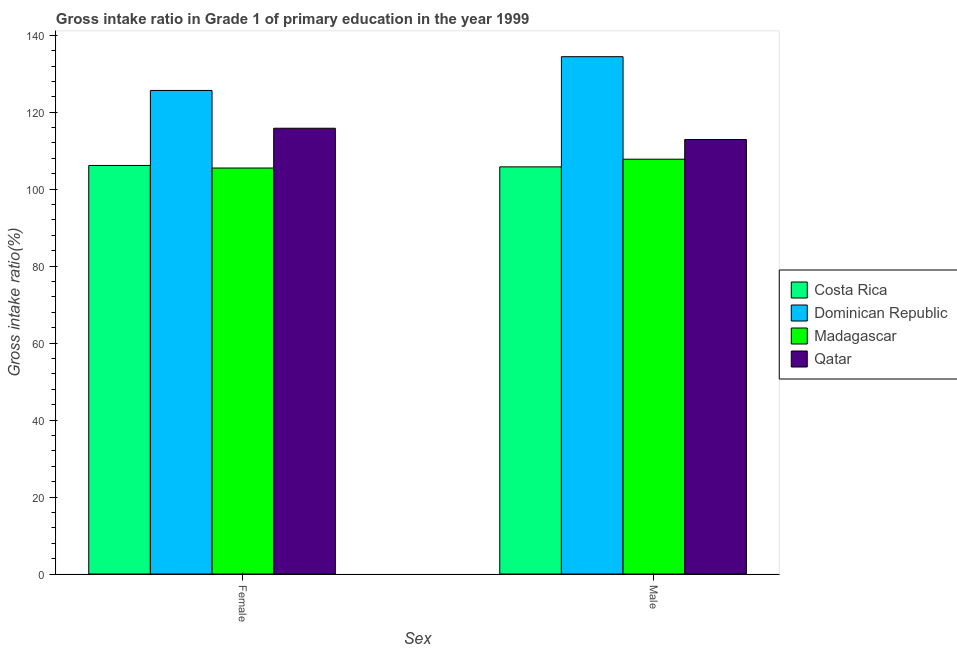How many different coloured bars are there?
Provide a succinct answer. 4. How many groups of bars are there?
Ensure brevity in your answer.  2. Are the number of bars per tick equal to the number of legend labels?
Offer a terse response. Yes. What is the gross intake ratio(male) in Qatar?
Ensure brevity in your answer.  112.9. Across all countries, what is the maximum gross intake ratio(female)?
Offer a terse response. 125.65. Across all countries, what is the minimum gross intake ratio(male)?
Provide a succinct answer. 105.8. In which country was the gross intake ratio(male) maximum?
Ensure brevity in your answer.  Dominican Republic. In which country was the gross intake ratio(female) minimum?
Provide a short and direct response. Madagascar. What is the total gross intake ratio(male) in the graph?
Provide a short and direct response. 460.91. What is the difference between the gross intake ratio(female) in Dominican Republic and that in Qatar?
Ensure brevity in your answer.  9.82. What is the difference between the gross intake ratio(male) in Dominican Republic and the gross intake ratio(female) in Madagascar?
Ensure brevity in your answer.  28.93. What is the average gross intake ratio(male) per country?
Make the answer very short. 115.23. What is the difference between the gross intake ratio(male) and gross intake ratio(female) in Dominican Republic?
Provide a short and direct response. 8.77. In how many countries, is the gross intake ratio(female) greater than 100 %?
Your response must be concise. 4. What is the ratio of the gross intake ratio(female) in Madagascar to that in Costa Rica?
Offer a very short reply. 0.99. What does the 3rd bar from the left in Female represents?
Provide a succinct answer. Madagascar. How many bars are there?
Ensure brevity in your answer.  8. Are all the bars in the graph horizontal?
Your answer should be very brief. No. How many countries are there in the graph?
Keep it short and to the point. 4. What is the difference between two consecutive major ticks on the Y-axis?
Make the answer very short. 20. Does the graph contain grids?
Offer a terse response. No. Where does the legend appear in the graph?
Your answer should be very brief. Center right. How many legend labels are there?
Your answer should be compact. 4. How are the legend labels stacked?
Your response must be concise. Vertical. What is the title of the graph?
Keep it short and to the point. Gross intake ratio in Grade 1 of primary education in the year 1999. What is the label or title of the X-axis?
Provide a succinct answer. Sex. What is the label or title of the Y-axis?
Keep it short and to the point. Gross intake ratio(%). What is the Gross intake ratio(%) in Costa Rica in Female?
Make the answer very short. 106.16. What is the Gross intake ratio(%) of Dominican Republic in Female?
Provide a succinct answer. 125.65. What is the Gross intake ratio(%) of Madagascar in Female?
Ensure brevity in your answer.  105.5. What is the Gross intake ratio(%) in Qatar in Female?
Your answer should be very brief. 115.83. What is the Gross intake ratio(%) of Costa Rica in Male?
Make the answer very short. 105.8. What is the Gross intake ratio(%) of Dominican Republic in Male?
Offer a very short reply. 134.42. What is the Gross intake ratio(%) of Madagascar in Male?
Give a very brief answer. 107.79. What is the Gross intake ratio(%) in Qatar in Male?
Your response must be concise. 112.9. Across all Sex, what is the maximum Gross intake ratio(%) in Costa Rica?
Your answer should be very brief. 106.16. Across all Sex, what is the maximum Gross intake ratio(%) in Dominican Republic?
Your response must be concise. 134.42. Across all Sex, what is the maximum Gross intake ratio(%) in Madagascar?
Offer a terse response. 107.79. Across all Sex, what is the maximum Gross intake ratio(%) in Qatar?
Your response must be concise. 115.83. Across all Sex, what is the minimum Gross intake ratio(%) of Costa Rica?
Your answer should be compact. 105.8. Across all Sex, what is the minimum Gross intake ratio(%) in Dominican Republic?
Your answer should be compact. 125.65. Across all Sex, what is the minimum Gross intake ratio(%) in Madagascar?
Provide a succinct answer. 105.5. Across all Sex, what is the minimum Gross intake ratio(%) in Qatar?
Offer a very short reply. 112.9. What is the total Gross intake ratio(%) of Costa Rica in the graph?
Offer a very short reply. 211.96. What is the total Gross intake ratio(%) of Dominican Republic in the graph?
Your answer should be very brief. 260.08. What is the total Gross intake ratio(%) of Madagascar in the graph?
Your response must be concise. 213.28. What is the total Gross intake ratio(%) of Qatar in the graph?
Your answer should be compact. 228.73. What is the difference between the Gross intake ratio(%) of Costa Rica in Female and that in Male?
Ensure brevity in your answer.  0.37. What is the difference between the Gross intake ratio(%) in Dominican Republic in Female and that in Male?
Your answer should be very brief. -8.77. What is the difference between the Gross intake ratio(%) of Madagascar in Female and that in Male?
Offer a very short reply. -2.29. What is the difference between the Gross intake ratio(%) of Qatar in Female and that in Male?
Give a very brief answer. 2.93. What is the difference between the Gross intake ratio(%) of Costa Rica in Female and the Gross intake ratio(%) of Dominican Republic in Male?
Ensure brevity in your answer.  -28.26. What is the difference between the Gross intake ratio(%) of Costa Rica in Female and the Gross intake ratio(%) of Madagascar in Male?
Your answer should be very brief. -1.63. What is the difference between the Gross intake ratio(%) of Costa Rica in Female and the Gross intake ratio(%) of Qatar in Male?
Make the answer very short. -6.74. What is the difference between the Gross intake ratio(%) of Dominican Republic in Female and the Gross intake ratio(%) of Madagascar in Male?
Offer a very short reply. 17.87. What is the difference between the Gross intake ratio(%) of Dominican Republic in Female and the Gross intake ratio(%) of Qatar in Male?
Provide a short and direct response. 12.75. What is the difference between the Gross intake ratio(%) in Madagascar in Female and the Gross intake ratio(%) in Qatar in Male?
Your answer should be compact. -7.41. What is the average Gross intake ratio(%) in Costa Rica per Sex?
Ensure brevity in your answer.  105.98. What is the average Gross intake ratio(%) in Dominican Republic per Sex?
Give a very brief answer. 130.04. What is the average Gross intake ratio(%) of Madagascar per Sex?
Offer a very short reply. 106.64. What is the average Gross intake ratio(%) in Qatar per Sex?
Offer a very short reply. 114.37. What is the difference between the Gross intake ratio(%) of Costa Rica and Gross intake ratio(%) of Dominican Republic in Female?
Provide a succinct answer. -19.49. What is the difference between the Gross intake ratio(%) in Costa Rica and Gross intake ratio(%) in Madagascar in Female?
Your answer should be very brief. 0.67. What is the difference between the Gross intake ratio(%) in Costa Rica and Gross intake ratio(%) in Qatar in Female?
Provide a short and direct response. -9.67. What is the difference between the Gross intake ratio(%) in Dominican Republic and Gross intake ratio(%) in Madagascar in Female?
Keep it short and to the point. 20.16. What is the difference between the Gross intake ratio(%) of Dominican Republic and Gross intake ratio(%) of Qatar in Female?
Give a very brief answer. 9.82. What is the difference between the Gross intake ratio(%) of Madagascar and Gross intake ratio(%) of Qatar in Female?
Make the answer very short. -10.34. What is the difference between the Gross intake ratio(%) in Costa Rica and Gross intake ratio(%) in Dominican Republic in Male?
Offer a very short reply. -28.63. What is the difference between the Gross intake ratio(%) of Costa Rica and Gross intake ratio(%) of Madagascar in Male?
Make the answer very short. -1.99. What is the difference between the Gross intake ratio(%) in Costa Rica and Gross intake ratio(%) in Qatar in Male?
Your response must be concise. -7.11. What is the difference between the Gross intake ratio(%) of Dominican Republic and Gross intake ratio(%) of Madagascar in Male?
Offer a terse response. 26.64. What is the difference between the Gross intake ratio(%) in Dominican Republic and Gross intake ratio(%) in Qatar in Male?
Your response must be concise. 21.52. What is the difference between the Gross intake ratio(%) in Madagascar and Gross intake ratio(%) in Qatar in Male?
Offer a terse response. -5.12. What is the ratio of the Gross intake ratio(%) in Costa Rica in Female to that in Male?
Make the answer very short. 1. What is the ratio of the Gross intake ratio(%) in Dominican Republic in Female to that in Male?
Keep it short and to the point. 0.93. What is the ratio of the Gross intake ratio(%) in Madagascar in Female to that in Male?
Make the answer very short. 0.98. What is the ratio of the Gross intake ratio(%) of Qatar in Female to that in Male?
Offer a terse response. 1.03. What is the difference between the highest and the second highest Gross intake ratio(%) in Costa Rica?
Give a very brief answer. 0.37. What is the difference between the highest and the second highest Gross intake ratio(%) in Dominican Republic?
Provide a short and direct response. 8.77. What is the difference between the highest and the second highest Gross intake ratio(%) in Madagascar?
Provide a short and direct response. 2.29. What is the difference between the highest and the second highest Gross intake ratio(%) of Qatar?
Provide a short and direct response. 2.93. What is the difference between the highest and the lowest Gross intake ratio(%) of Costa Rica?
Offer a terse response. 0.37. What is the difference between the highest and the lowest Gross intake ratio(%) in Dominican Republic?
Your answer should be compact. 8.77. What is the difference between the highest and the lowest Gross intake ratio(%) of Madagascar?
Give a very brief answer. 2.29. What is the difference between the highest and the lowest Gross intake ratio(%) in Qatar?
Offer a very short reply. 2.93. 